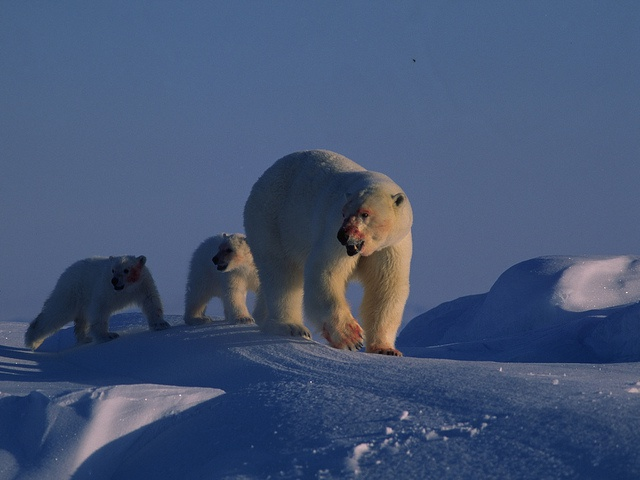Describe the objects in this image and their specific colors. I can see bear in blue, black, gray, and tan tones, bear in blue, black, navy, gray, and darkblue tones, and bear in blue, navy, black, and gray tones in this image. 